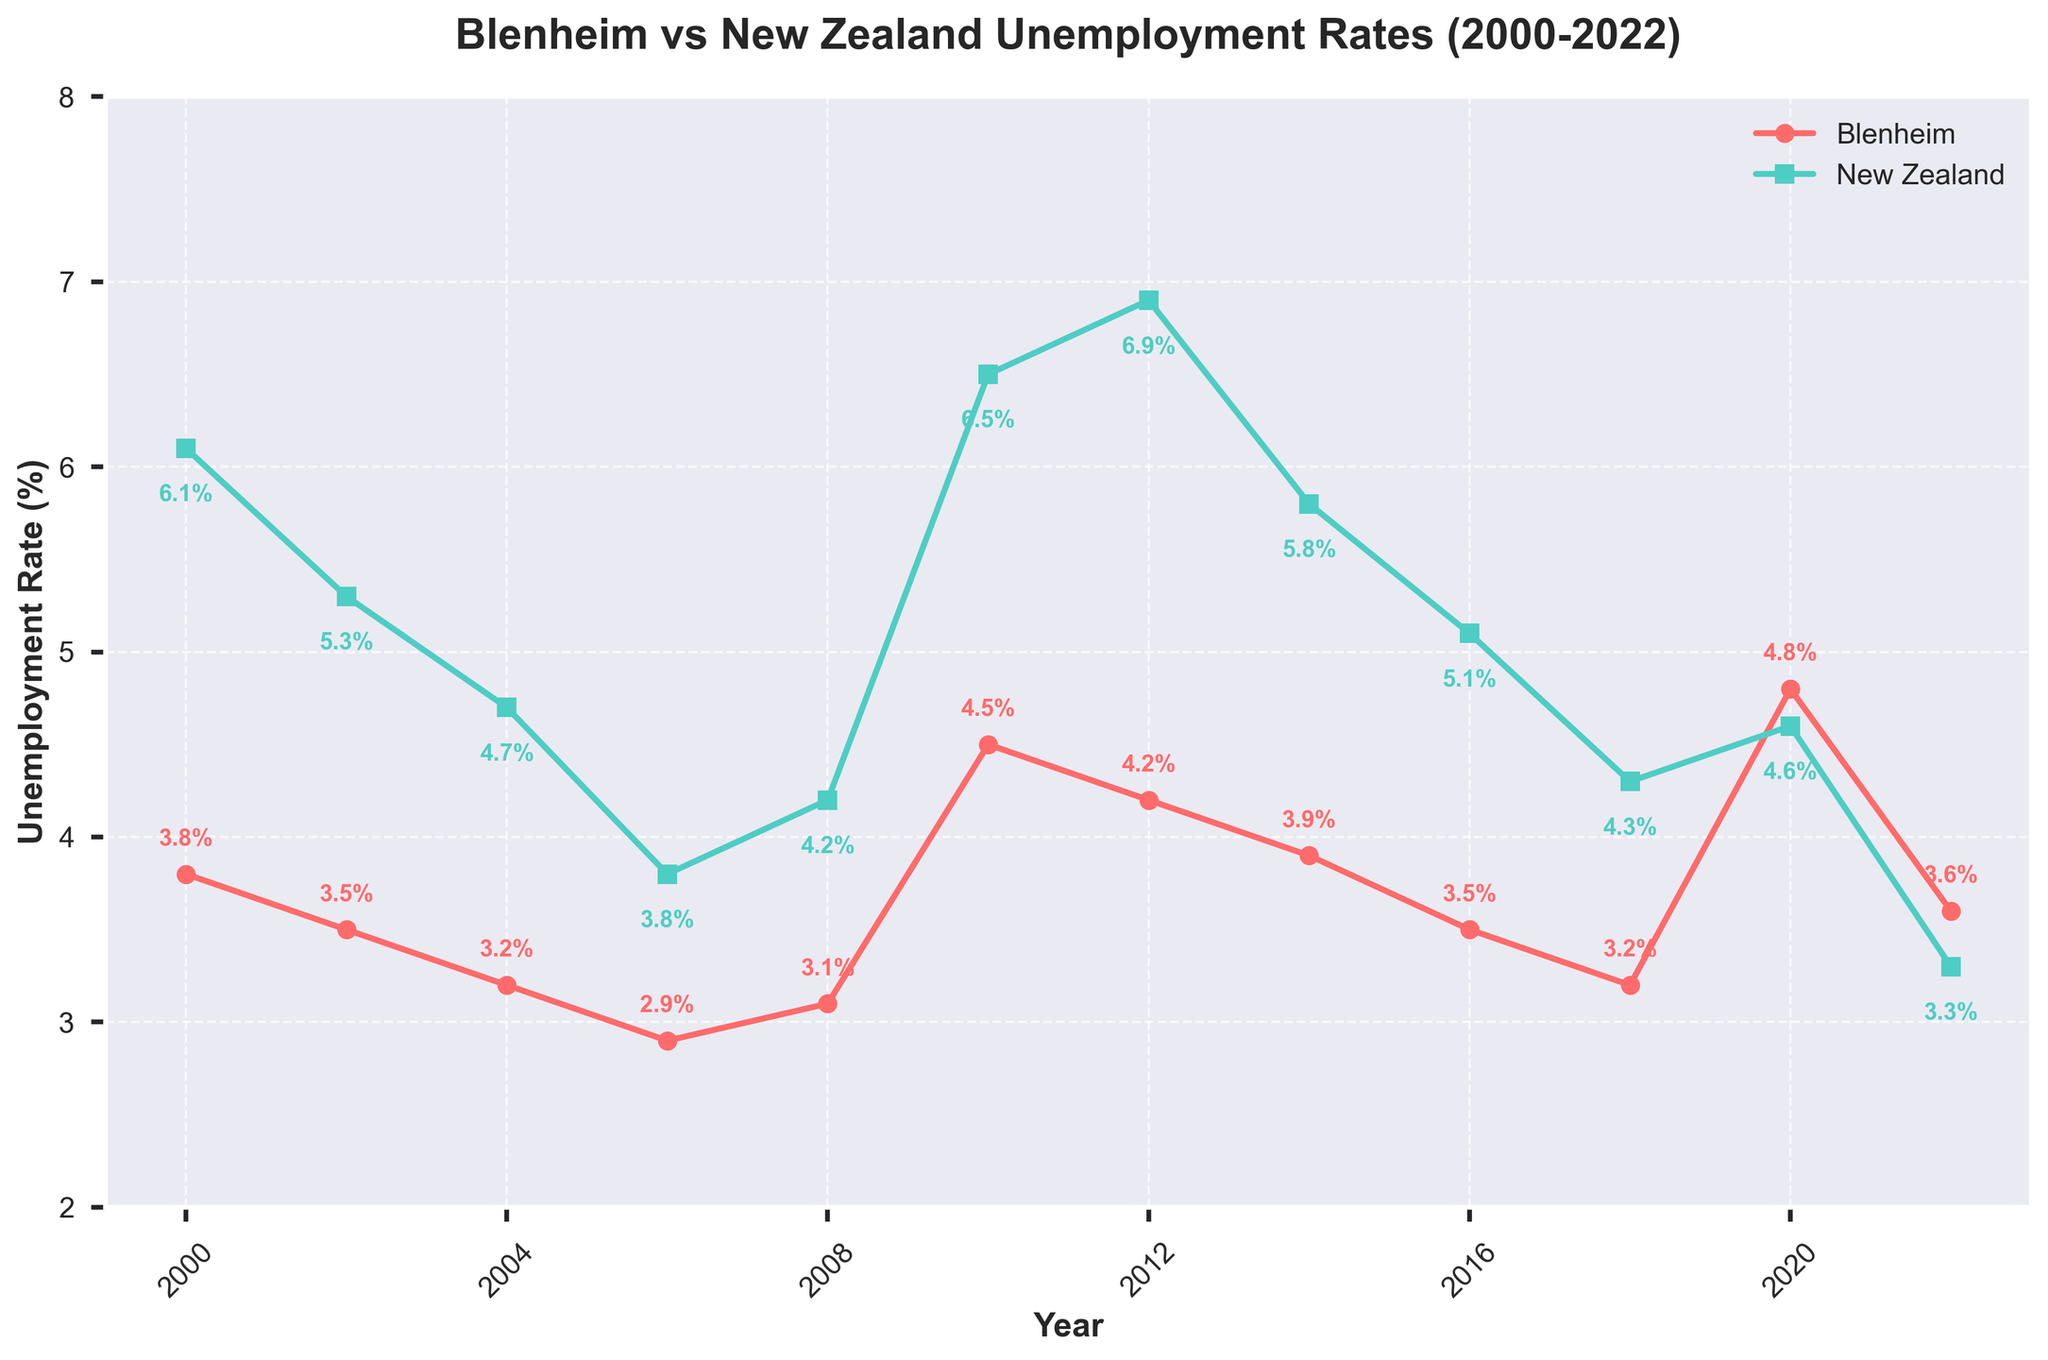What year did Blenheim have its highest unemployment rate? Look at the plot for the highest point on the Blenheim line. The peak occurs at 4.8% in 2020.
Answer: 2020 Which year had the smallest difference between Blenheim's and New Zealand's unemployment rates? Compare the vertical distance between the Blenheim and New Zealand points for each year. The difference is smallest in 2020 when Blenheim is at 4.8% and New Zealand is at 4.6%, a difference of 0.2%.
Answer: 2020 Does Blenheim generally have a higher or lower unemployment rate compared to the national average? Observe the relative positions of the Blenheim and New Zealand lines. The Blenheim line is typically below the New Zealand line, indicating a lower unemployment rate.
Answer: Lower In what year did New Zealand's unemployment rate reach its peak in the dataset? Look at the plot for the highest point on the New Zealand line. It peaks at 6.9% in 2012.
Answer: 2012 What is the average unemployment rate for Blenheim from 2000 to 2022? Sum the percentages for all years for Blenheim and divide by the number of years. (3.8+3.5+3.2+2.9+3.1+4.5+4.2+3.9+3.5+3.2+4.8+3.6) / 12 = 3.6%
Answer: 3.6% Between which consecutive years did Blenheim see the largest increase in unemployment rate? Compare the increases between each consecutive year by checking the slope of the Blenheim line. The largest increase occurs from 2008 (3.1%) to 2010 (4.5%), which is an increase of 1.4%.
Answer: 2008-2010 How did Blenheim's unemployment rate compare to the national average in 2006? Look at the data points for 2006 where Blenheim is at 2.9% and New Zealand is at 3.8%. Blenheim's rate is lower.
Answer: Lower Which year shows the greatest reduction in the national unemployment rate compared to the previous data point? Calculate the reductions for each pair of consecutive years on the New Zealand line. For 2012 to 2014, the reduction is from 6.9% to 5.8%, a reduction of 1.1%.
Answer: 2012-2014 What can be inferred about the unemployment trend in Blenheim from 2016 to 2022? Observe the trend of the Blenheim line from 2016 to 2022. The rate decreases from 3.5% in 2016 to 3.2% in 2018, then increases to 4.8% in 2020, and slightly decreases again to 3.6% in 2022.
Answer: Mixed trend 